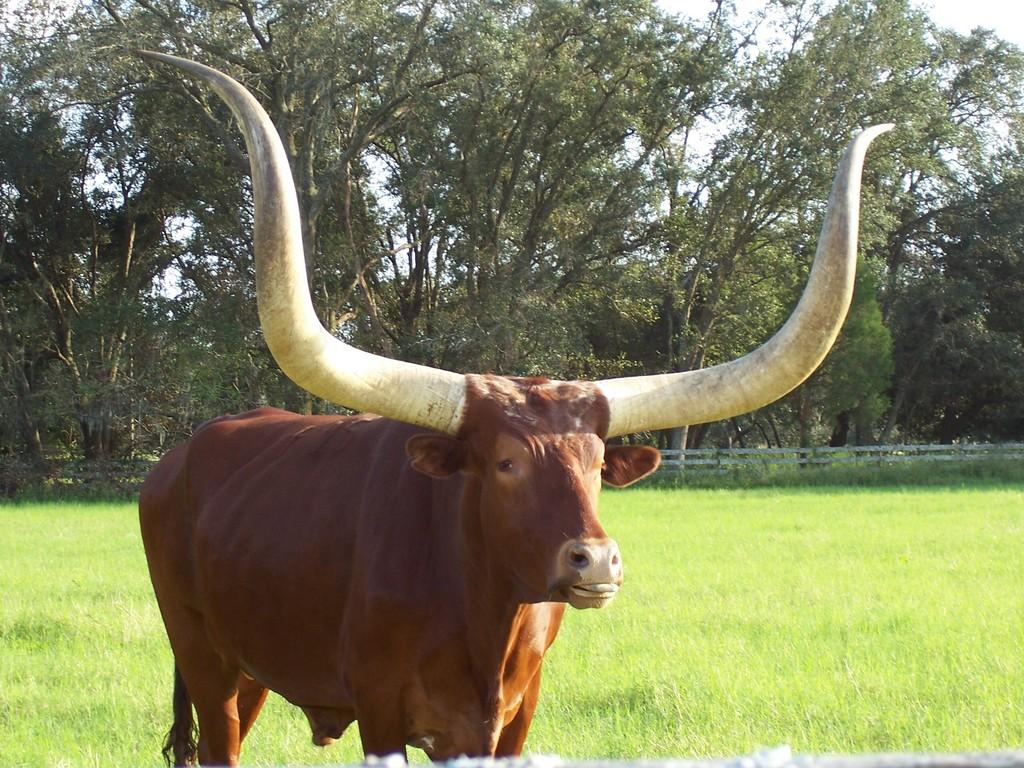What type of animal can be seen in the image? There is an animal in the image, but its specific type cannot be determined from the provided facts. Where is the animal located in the image? The animal is standing on grassland in the image. What is the surrounding environment like in the image? There is a fence and trees in the background of the image, and the sky is visible in the background as well. What color is the jar that the animal is holding in the image? There is no jar present in the image, and the animal is not holding anything. 